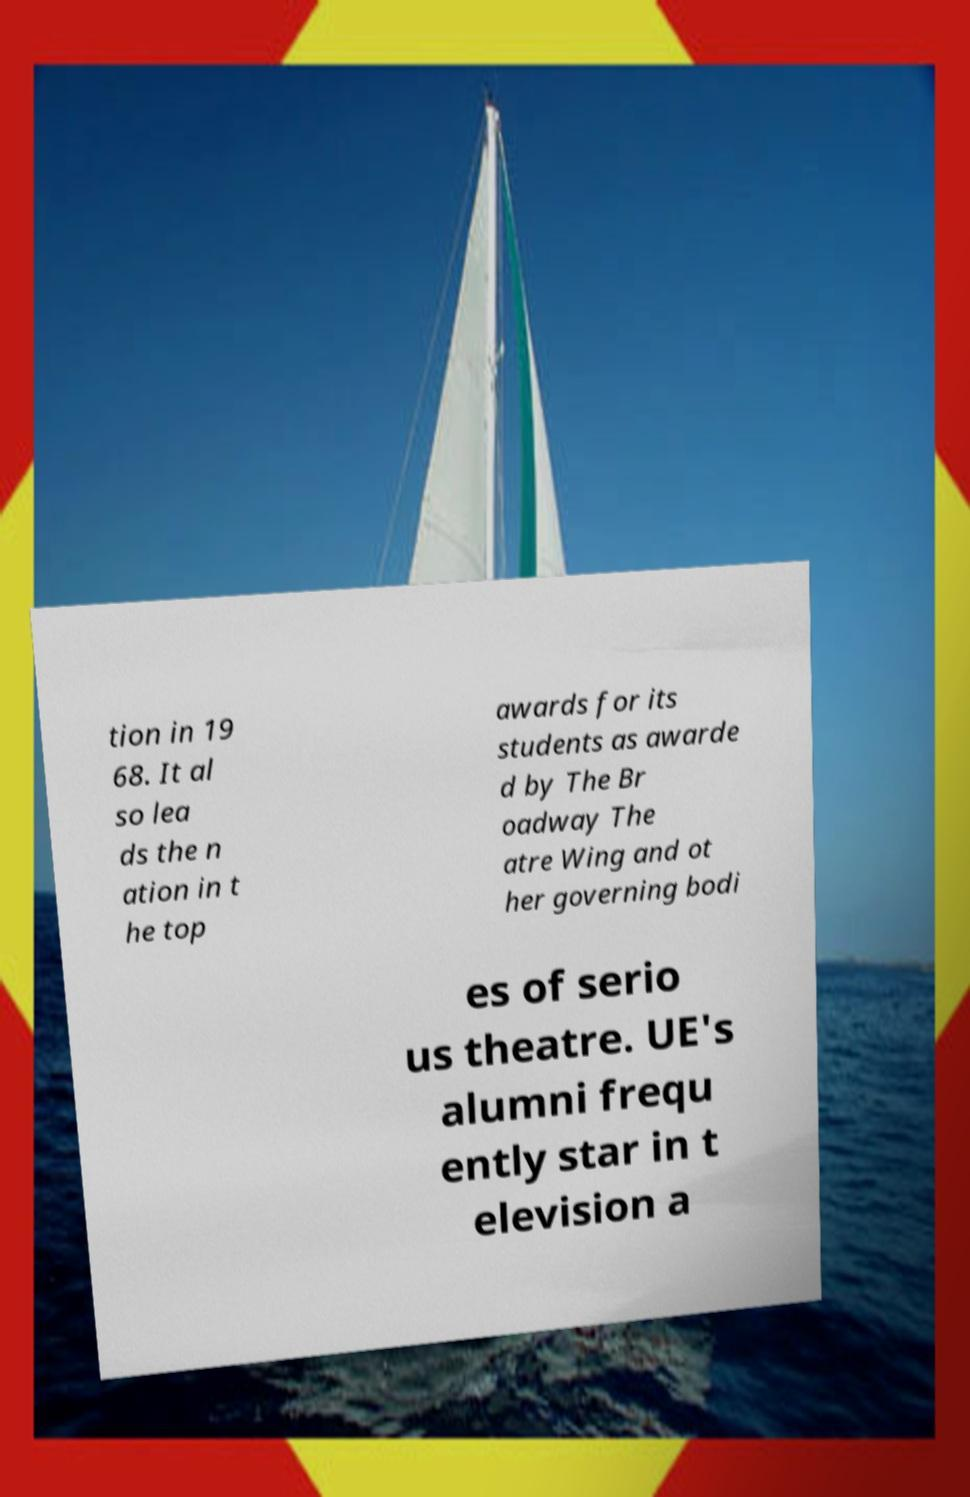For documentation purposes, I need the text within this image transcribed. Could you provide that? tion in 19 68. It al so lea ds the n ation in t he top awards for its students as awarde d by The Br oadway The atre Wing and ot her governing bodi es of serio us theatre. UE's alumni frequ ently star in t elevision a 